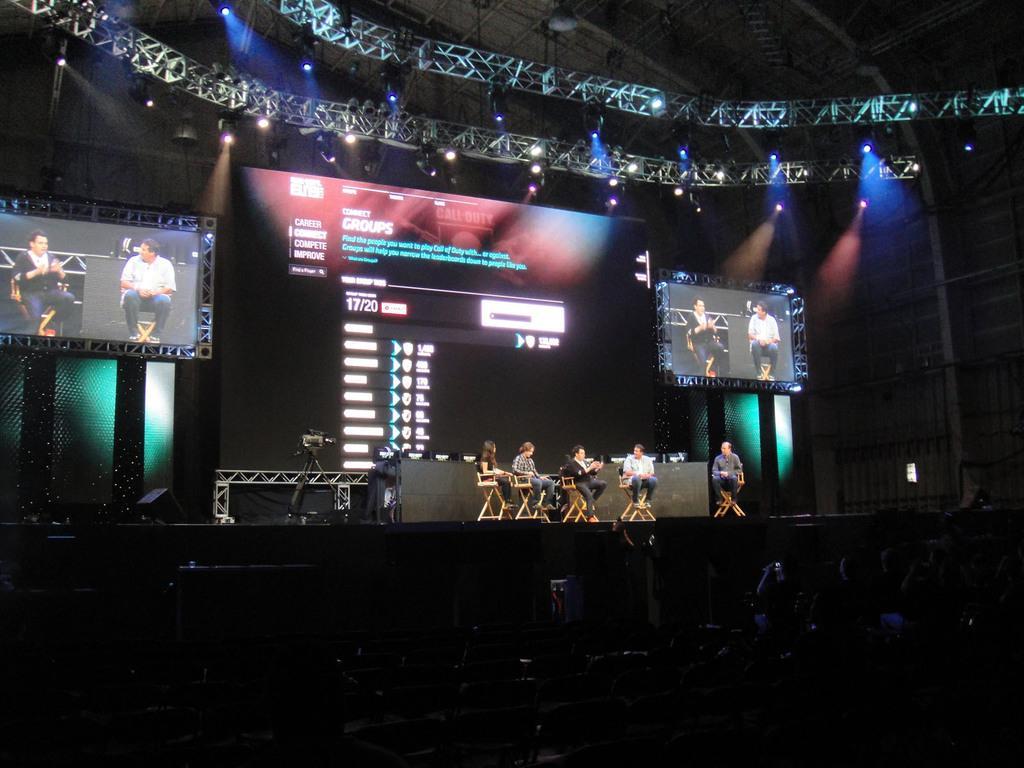How would you summarize this image in a sentence or two? In this image there is a stage on which there are five persons sitting on the chairs one beside the other. Behind them there is a screen. At the top there are two screens on either side of the image. At the top there are lights which are attached to the stand. At the bottom there are few people sitting in the chairs. This image is taken during the night time. 